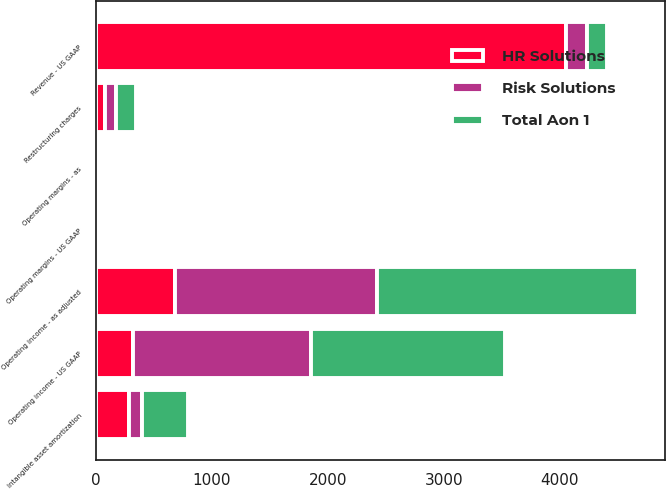Convert chart to OTSL. <chart><loc_0><loc_0><loc_500><loc_500><stacked_bar_chart><ecel><fcel>Revenue - US GAAP<fcel>Operating income - US GAAP<fcel>Restructuring charges<fcel>Intangible asset amortization<fcel>Operating income - as adjusted<fcel>Operating margins - US GAAP<fcel>Operating margins - as<nl><fcel>Total Aon 1<fcel>174<fcel>1671<fcel>174<fcel>395<fcel>2245<fcel>14.1<fcel>19<nl><fcel>Risk Solutions<fcel>174<fcel>1540<fcel>94<fcel>115<fcel>1749<fcel>19.8<fcel>22.5<nl><fcel>HR Solutions<fcel>4057<fcel>318<fcel>80<fcel>280<fcel>678<fcel>7.8<fcel>16.7<nl></chart> 